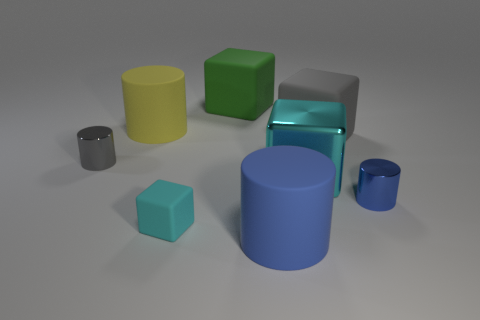Subtract 1 cylinders. How many cylinders are left? 3 Subtract all purple cubes. Subtract all cyan balls. How many cubes are left? 4 Add 2 tiny cyan shiny cylinders. How many objects exist? 10 Subtract 1 blue cylinders. How many objects are left? 7 Subtract all red matte cylinders. Subtract all tiny blue objects. How many objects are left? 7 Add 2 cylinders. How many cylinders are left? 6 Add 8 tiny metal objects. How many tiny metal objects exist? 10 